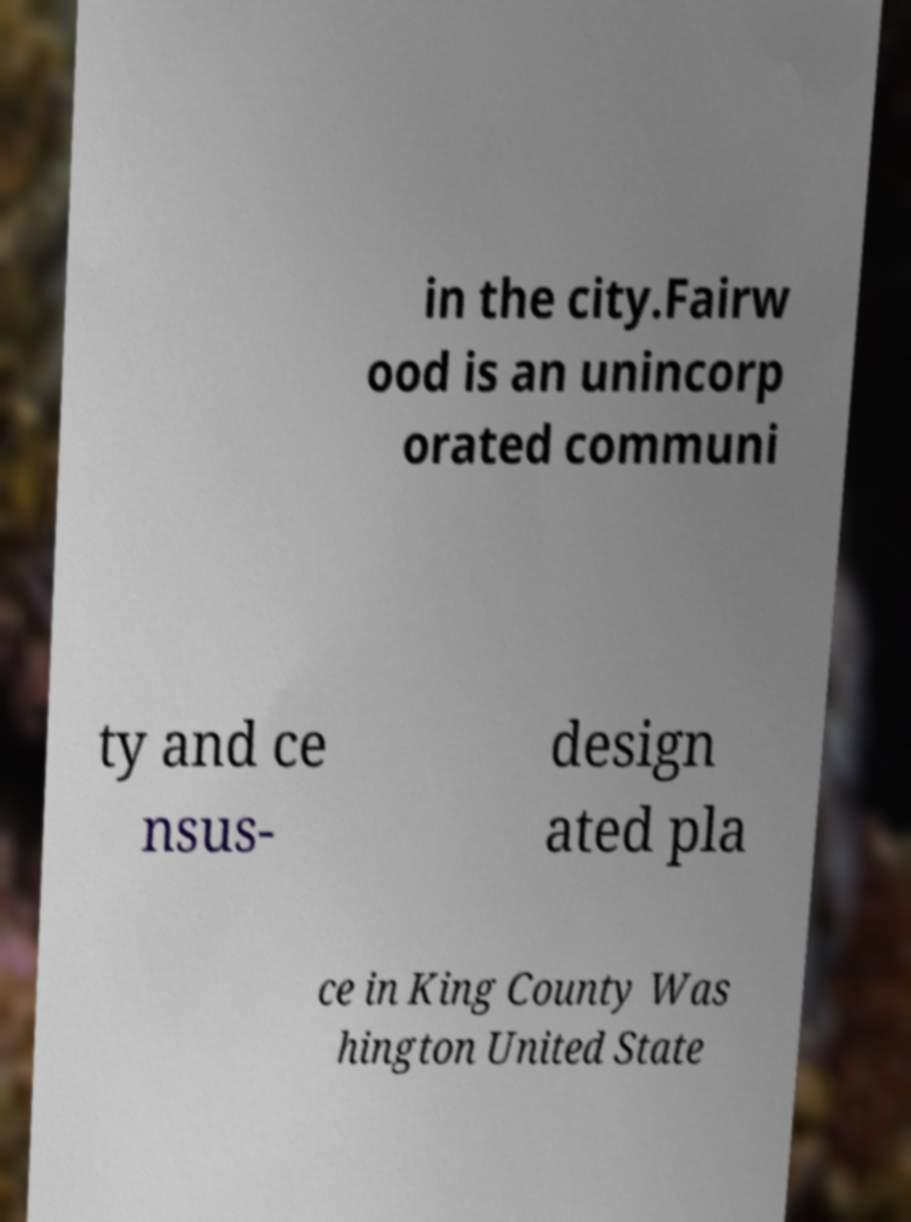What messages or text are displayed in this image? I need them in a readable, typed format. in the city.Fairw ood is an unincorp orated communi ty and ce nsus- design ated pla ce in King County Was hington United State 